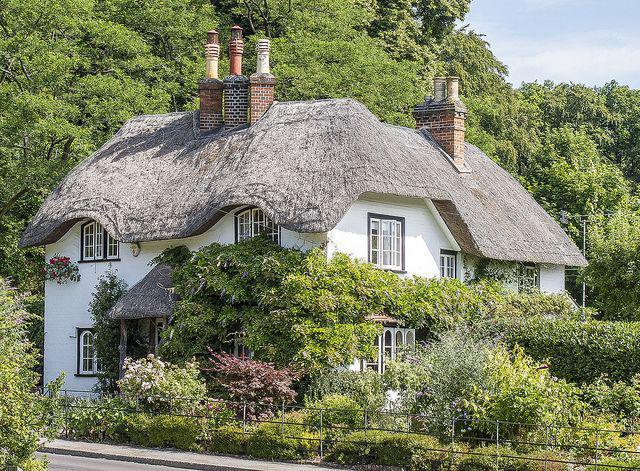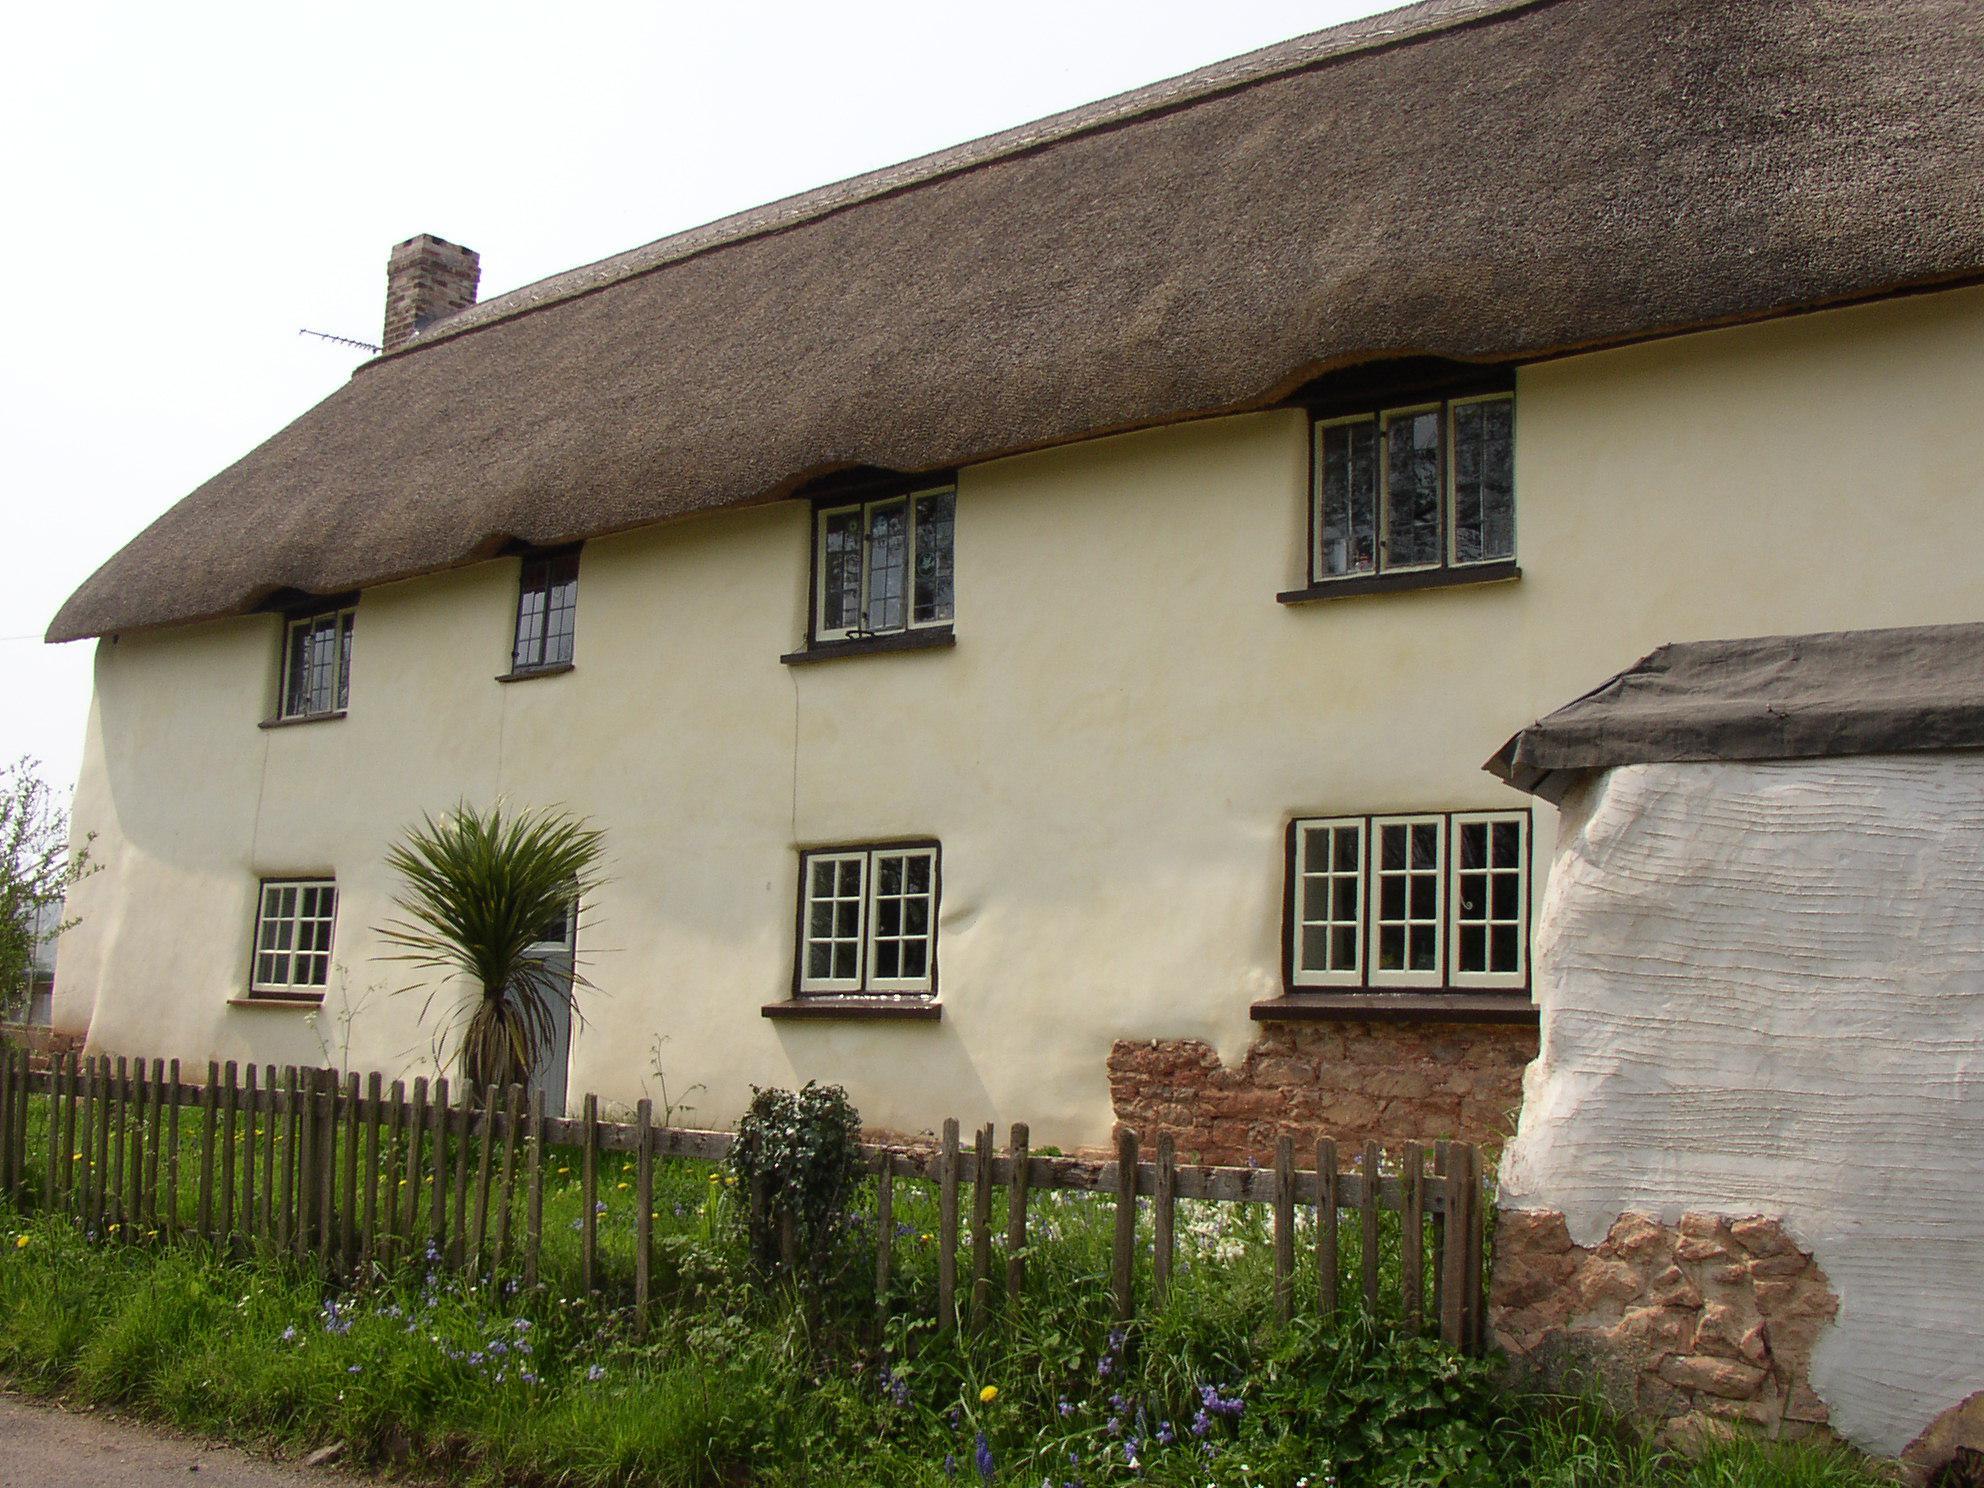The first image is the image on the left, the second image is the image on the right. Analyze the images presented: Is the assertion "A fence runs around the house in the image on the right." valid? Answer yes or no. Yes. The first image is the image on the left, the second image is the image on the right. Evaluate the accuracy of this statement regarding the images: "A building with a shaggy thatched roof topped with a notched border has two projecting dormer windows and stone columns at the entrance to the property.". Is it true? Answer yes or no. No. 